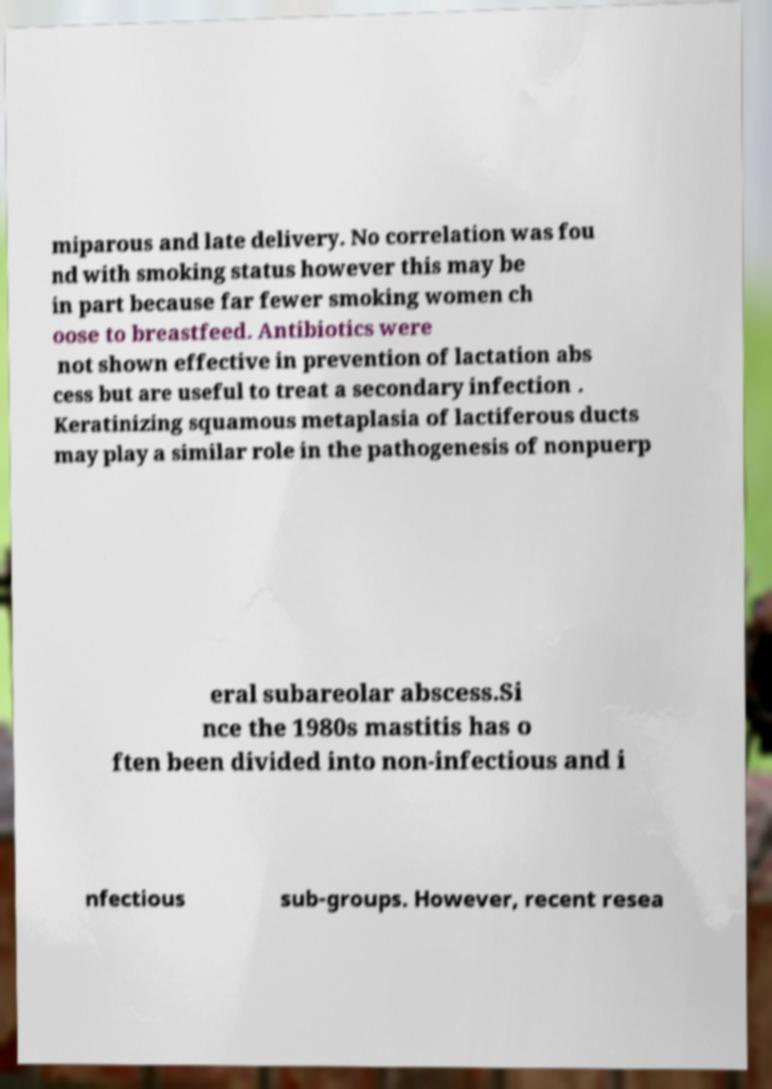Can you read and provide the text displayed in the image?This photo seems to have some interesting text. Can you extract and type it out for me? miparous and late delivery. No correlation was fou nd with smoking status however this may be in part because far fewer smoking women ch oose to breastfeed. Antibiotics were not shown effective in prevention of lactation abs cess but are useful to treat a secondary infection . Keratinizing squamous metaplasia of lactiferous ducts may play a similar role in the pathogenesis of nonpuerp eral subareolar abscess.Si nce the 1980s mastitis has o ften been divided into non-infectious and i nfectious sub-groups. However, recent resea 